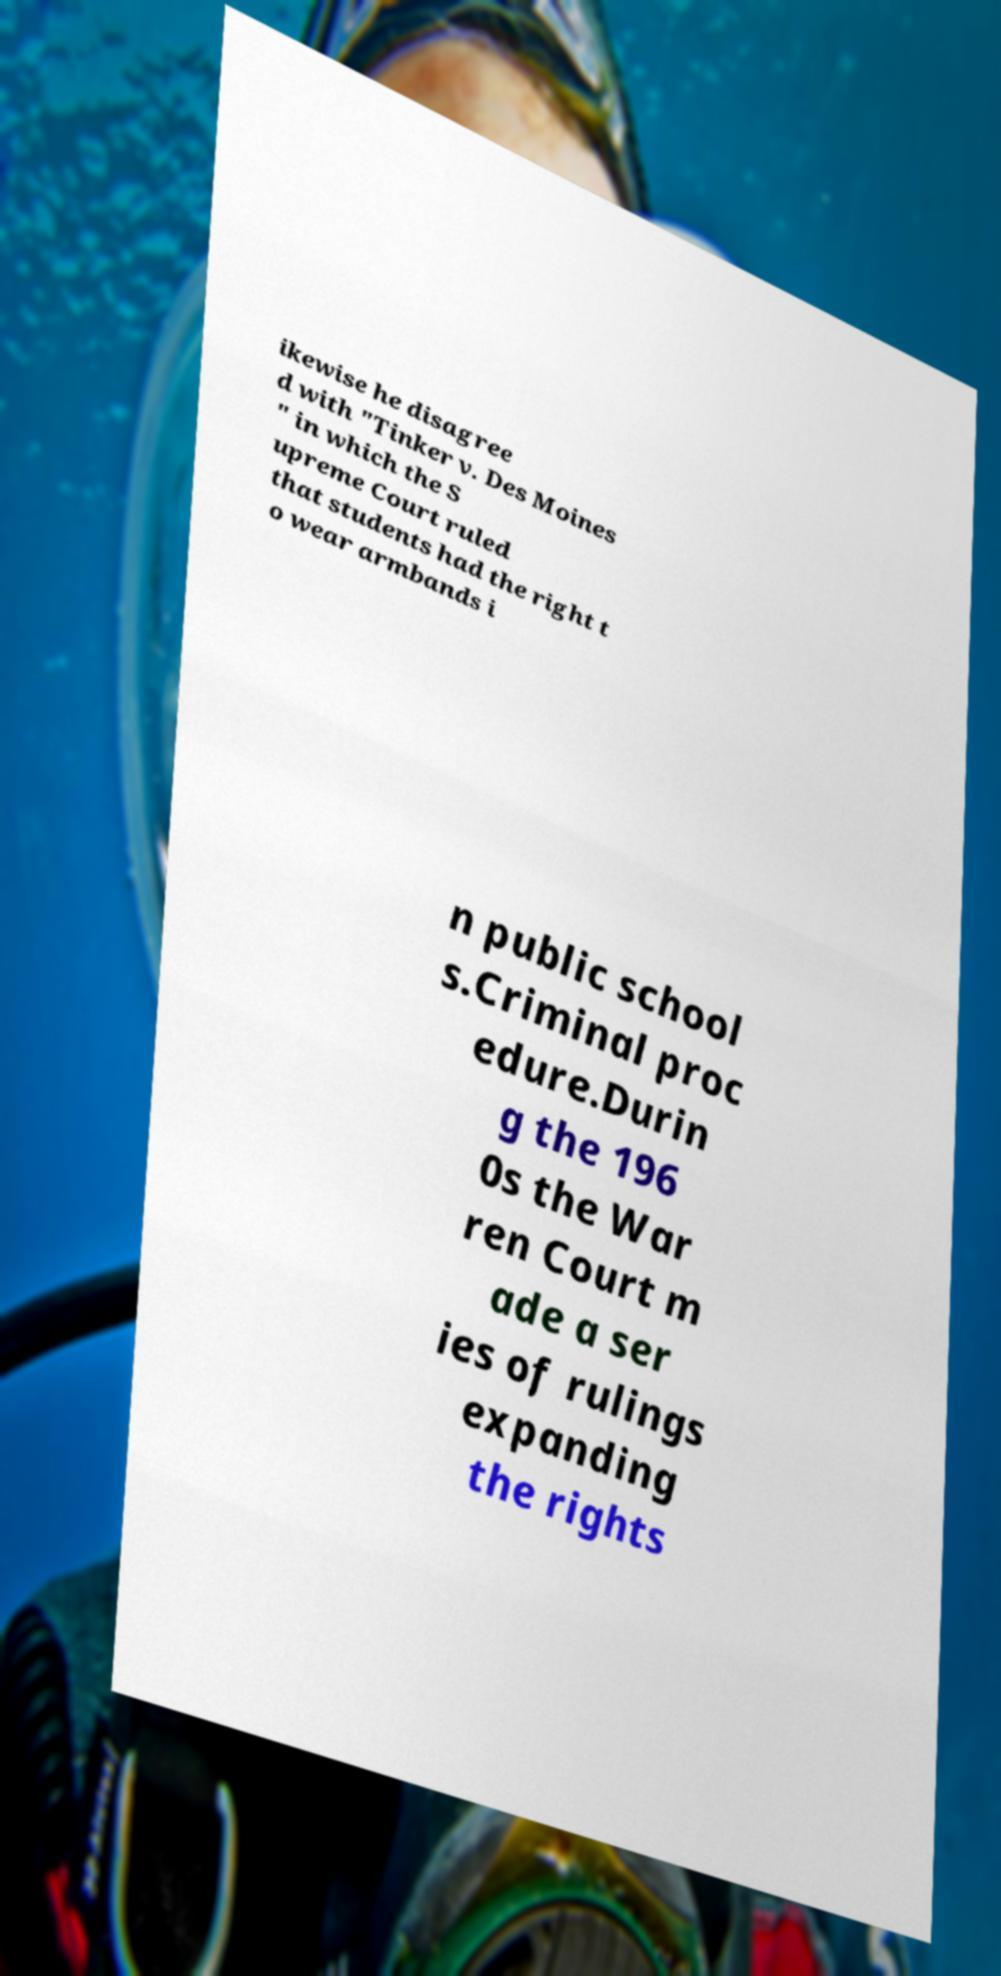Could you extract and type out the text from this image? ikewise he disagree d with "Tinker v. Des Moines " in which the S upreme Court ruled that students had the right t o wear armbands i n public school s.Criminal proc edure.Durin g the 196 0s the War ren Court m ade a ser ies of rulings expanding the rights 